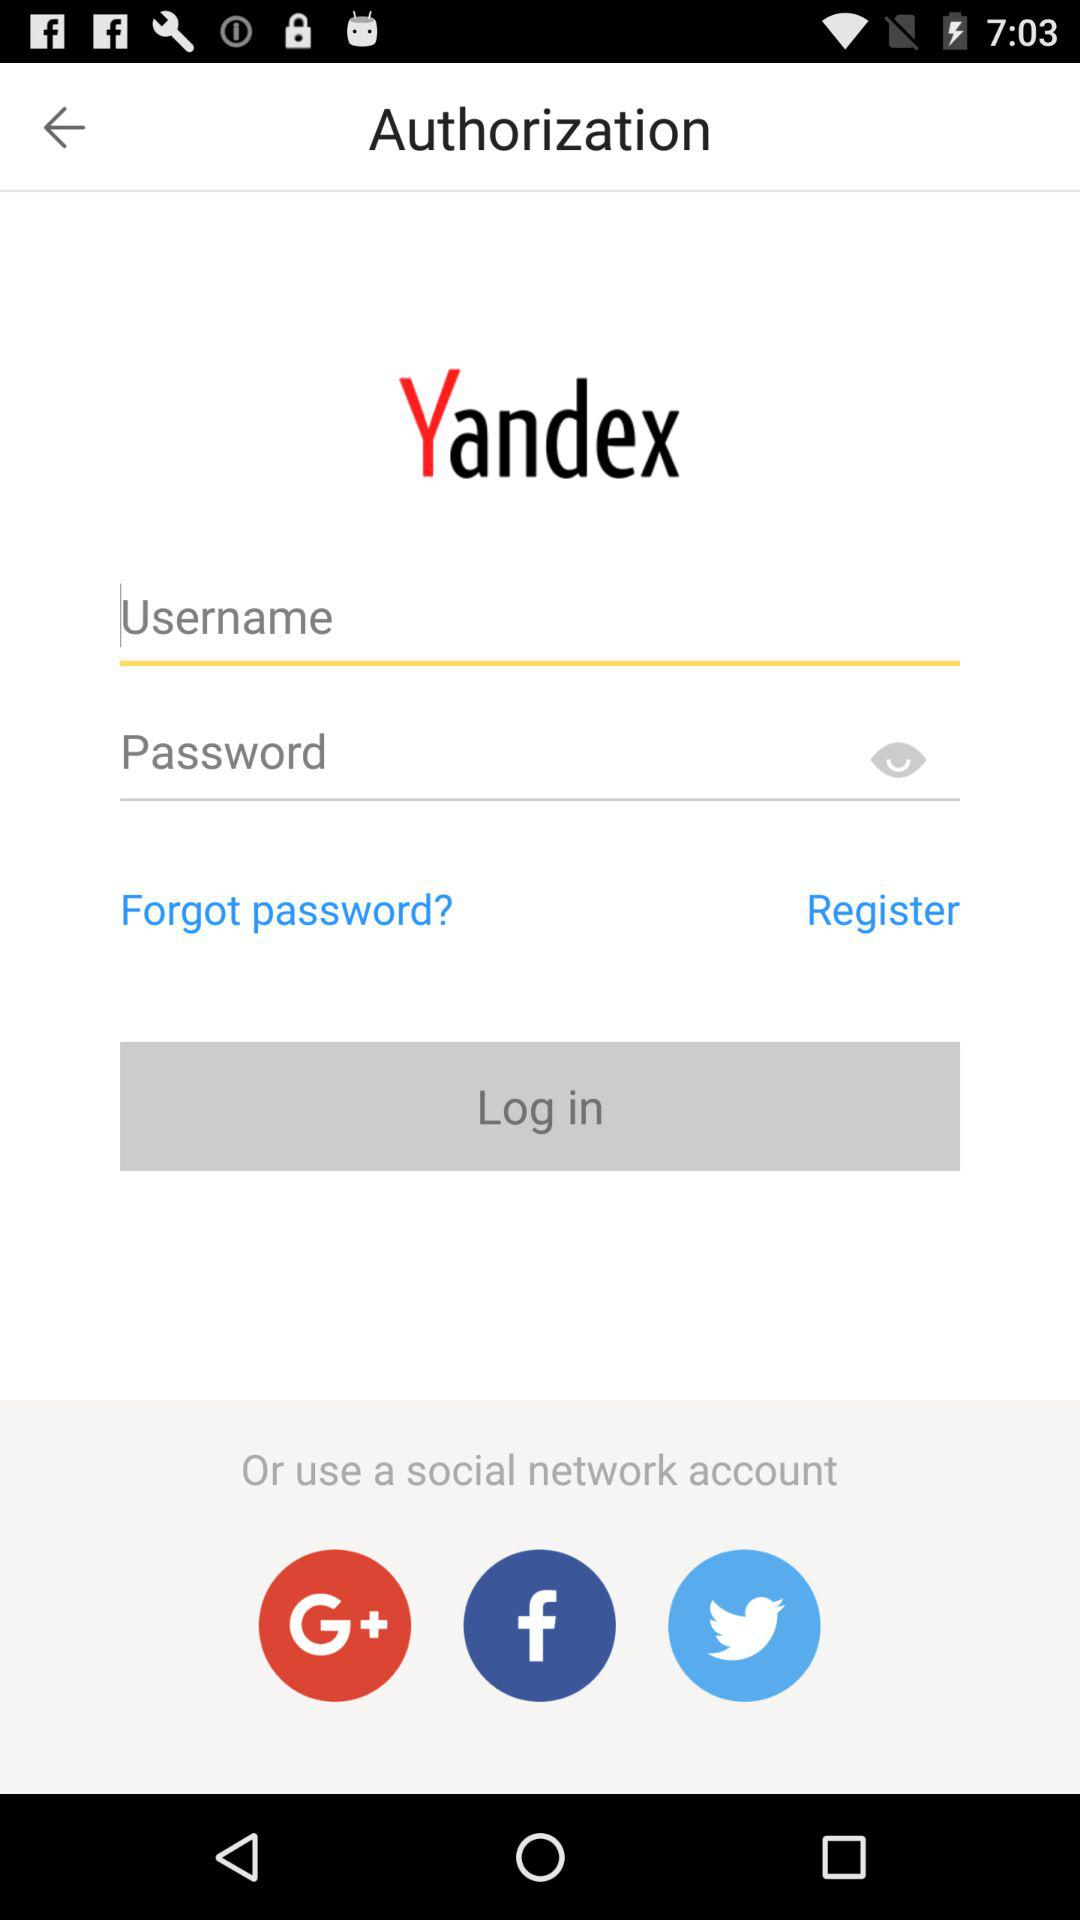Which application can be used as a social network account? The applications are "Google+", "Facebook" and "Twitter". 